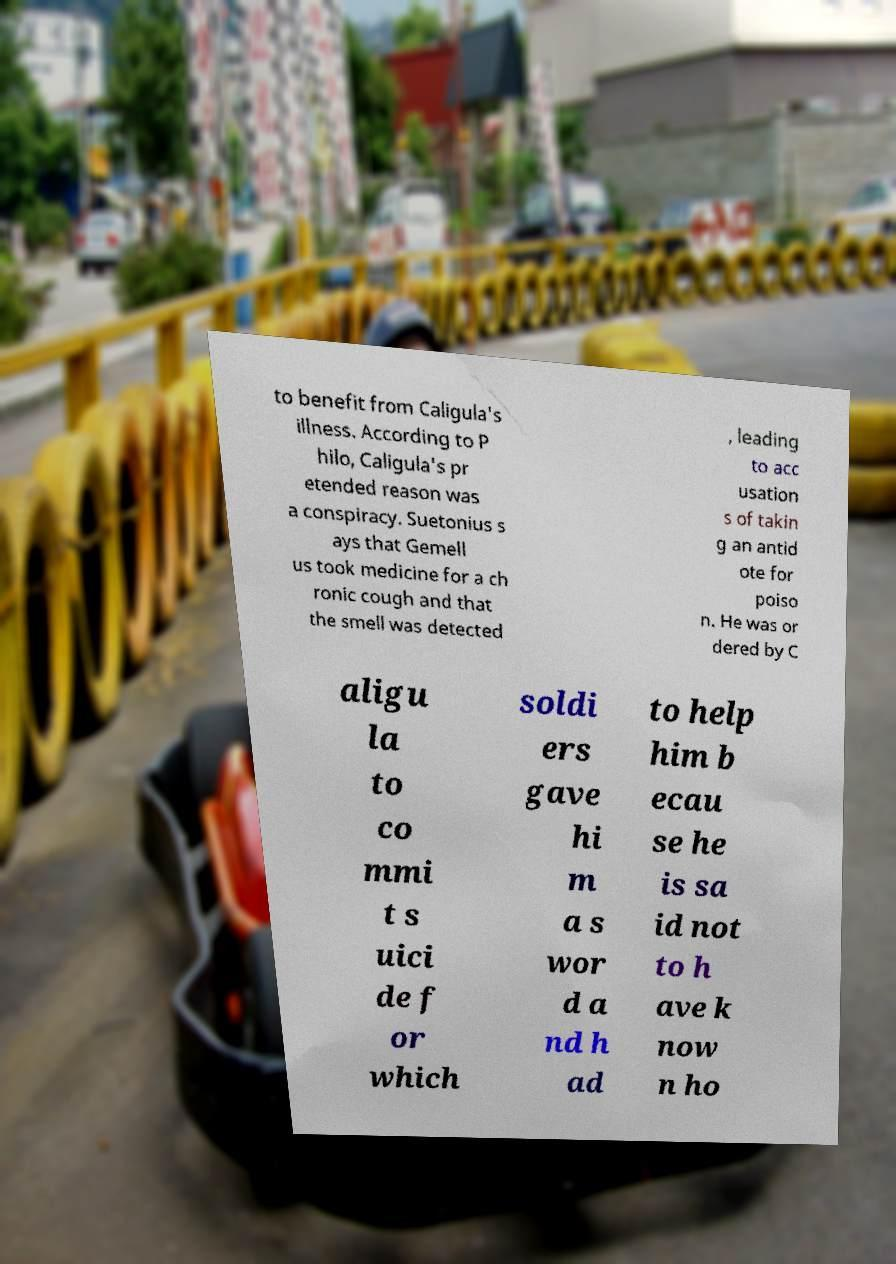Could you assist in decoding the text presented in this image and type it out clearly? to benefit from Caligula's illness. According to P hilo, Caligula's pr etended reason was a conspiracy. Suetonius s ays that Gemell us took medicine for a ch ronic cough and that the smell was detected , leading to acc usation s of takin g an antid ote for poiso n. He was or dered by C aligu la to co mmi t s uici de f or which soldi ers gave hi m a s wor d a nd h ad to help him b ecau se he is sa id not to h ave k now n ho 